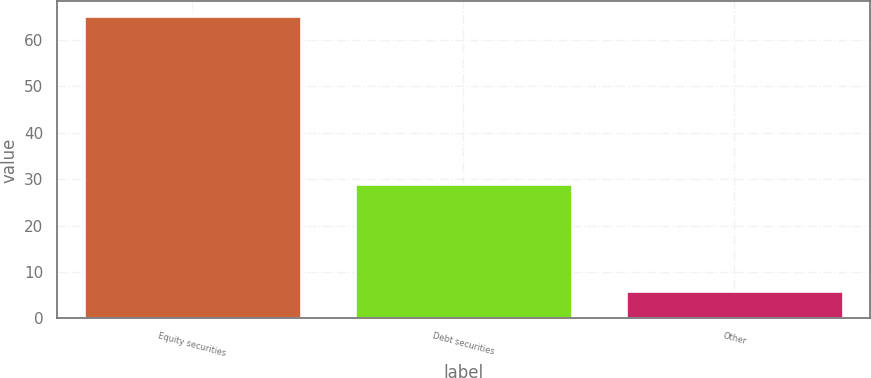Convert chart. <chart><loc_0><loc_0><loc_500><loc_500><bar_chart><fcel>Equity securities<fcel>Debt securities<fcel>Other<nl><fcel>65<fcel>29<fcel>6<nl></chart> 